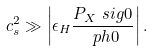<formula> <loc_0><loc_0><loc_500><loc_500>c _ { s } ^ { 2 } \gg \left | \epsilon _ { H } \frac { P _ { X } \ s i g 0 } { \ p h 0 } \right | .</formula> 